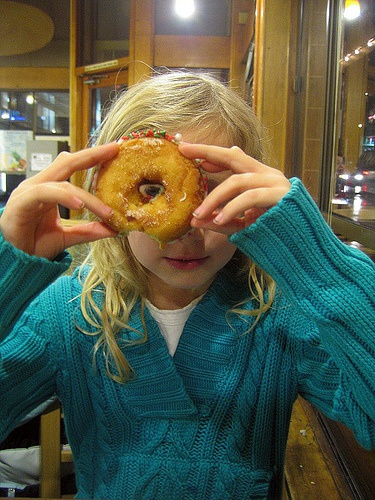Describe the objects in this image and their specific colors. I can see people in black, teal, brown, and olive tones, donut in black, olive, orange, maroon, and tan tones, and chair in black, olive, and gray tones in this image. 